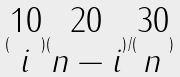<formula> <loc_0><loc_0><loc_500><loc_500>( \begin{matrix} 1 0 \\ i \end{matrix} ) ( \begin{matrix} 2 0 \\ n - i \end{matrix} ) / ( \begin{matrix} 3 0 \\ n \end{matrix} )</formula> 